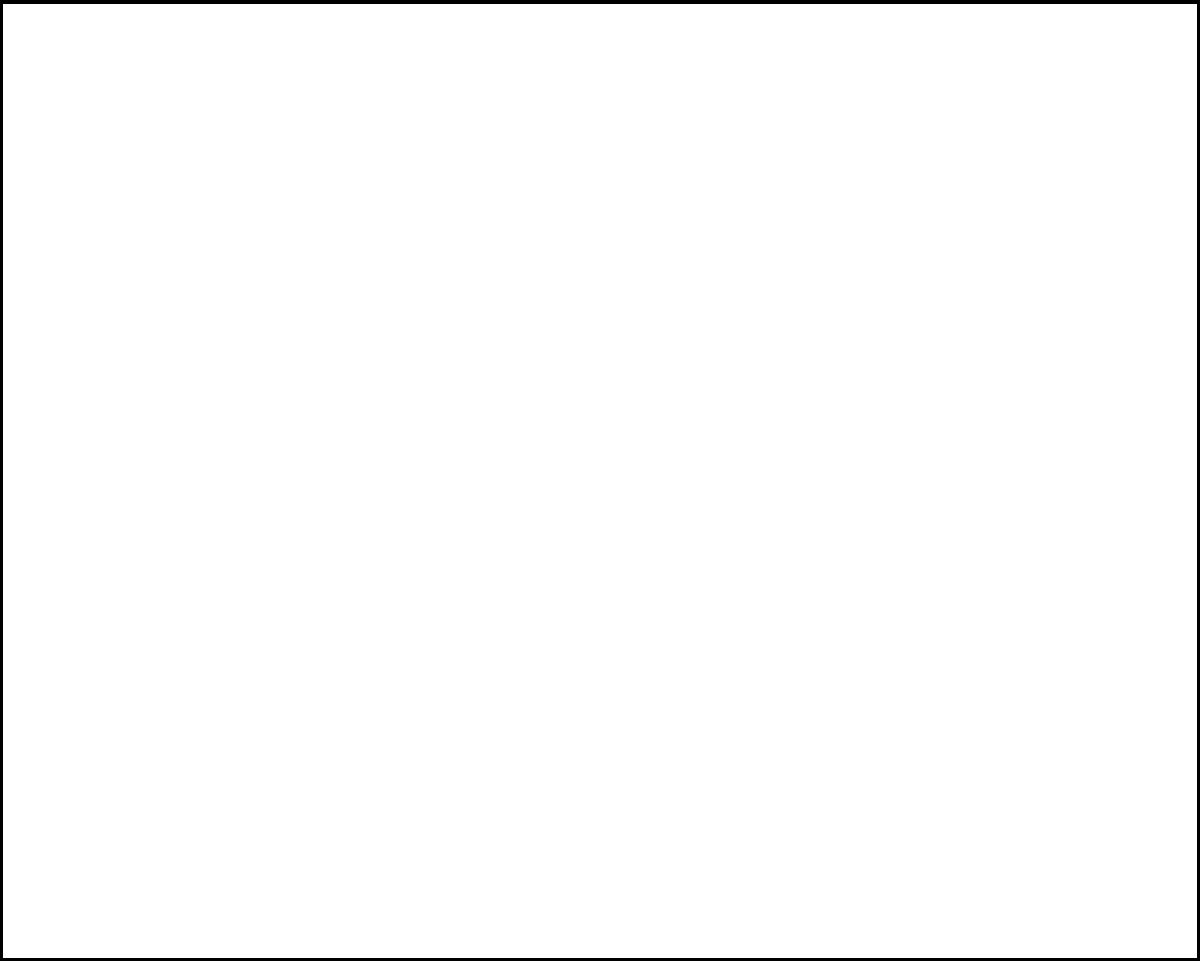A sukkah is a temporary dwelling used during the festival of Sukkot. According to Jewish law, it must have a minimum height of 10 handbreadths (approximately 80 cm) and a minimum base area of 7x7 handbreadths (approximately 56x56 cm). For practical reasons, the maximum height is limited to 20 amot (approximately 9.6 meters).

Given that the sukkah must be constructed using a fixed amount of material for the walls, and assuming the roof is made separately, find the dimensions (length $a$, width $b$, and height $h$) that maximize the volume of the sukkah. Express your answer in terms of the total area of material available for the walls, $S$. Let's approach this step-by-step:

1) The volume of the sukkah is given by $V = abh$.

2) The surface area of the walls is given by $S = 2ah + 2bh$ (excluding the base and roof).

3) We need to maximize $V$ subject to the constraint $S = 2ah + 2bh$.

4) From the constraint, we can express $h$ in terms of $a$ and $b$:
   $h = \frac{S}{2(a+b)}$

5) Substituting this into the volume equation:
   $V = ab \cdot \frac{S}{2(a+b)} = \frac{abS}{2(a+b)}$

6) To find the maximum, we need to differentiate $V$ with respect to $a$ and $b$ and set both derivatives to zero:

   $\frac{\partial V}{\partial a} = \frac{bS(a+b) - abS}{2(a+b)^2} = 0$
   $\frac{\partial V}{\partial b} = \frac{aS(a+b) - abS}{2(a+b)^2} = 0$

7) Solving these equations:
   $bS(a+b) - abS = 0$
   $aS(a+b) - abS = 0$

   These are equivalent to:
   $b^2 = a^2$

8) Therefore, $a = b$ for the maximum volume.

9) Substituting this back into the constraint equation:
   $S = 2ah + 2ah = 4ah$
   $h = \frac{S}{4a}$

10) Since $a = b$, we have:
    $a = b = \sqrt{\frac{S}{4}}$
    $h = \frac{S}{4\sqrt{\frac{S}{4}}} = \sqrt{\frac{S}{4}}$

Therefore, to maximize the volume, the sukkah should be a cube with all dimensions equal to $\sqrt{\frac{S}{4}}$.
Answer: $a = b = h = \sqrt{\frac{S}{4}}$ 